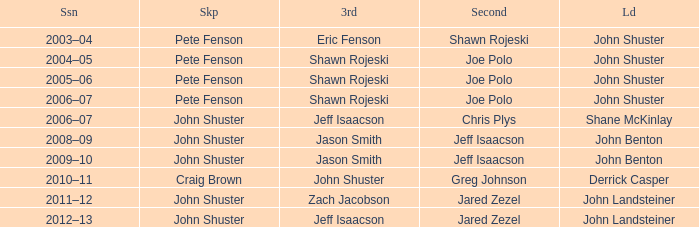Who was the lead with Pete Fenson as skip and Joe Polo as second in season 2005–06? John Shuster. 